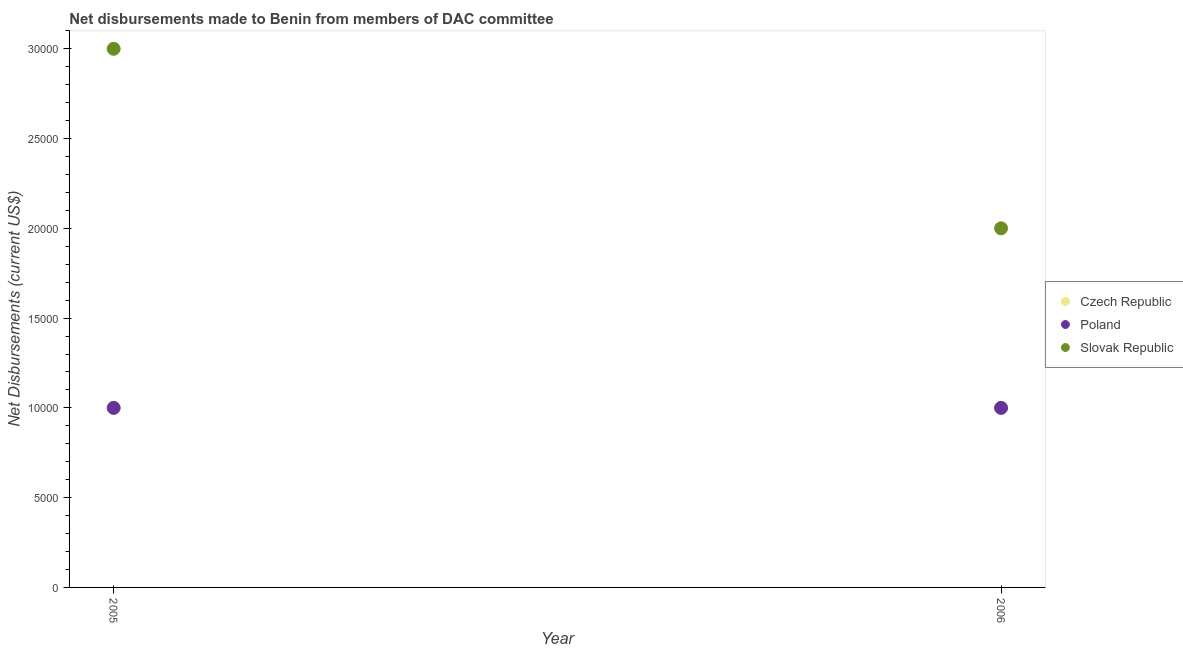How many different coloured dotlines are there?
Your response must be concise. 3. What is the net disbursements made by slovak republic in 2005?
Offer a terse response. 3.00e+04. Across all years, what is the maximum net disbursements made by poland?
Make the answer very short. 10000. Across all years, what is the minimum net disbursements made by slovak republic?
Ensure brevity in your answer.  2.00e+04. What is the total net disbursements made by czech republic in the graph?
Provide a short and direct response. 2.00e+04. What is the difference between the net disbursements made by poland in 2005 and that in 2006?
Give a very brief answer. 0. What is the difference between the net disbursements made by slovak republic in 2006 and the net disbursements made by czech republic in 2005?
Ensure brevity in your answer.  10000. In the year 2006, what is the difference between the net disbursements made by czech republic and net disbursements made by poland?
Provide a short and direct response. 0. In how many years, is the net disbursements made by poland greater than 19000 US$?
Give a very brief answer. 0. What is the ratio of the net disbursements made by slovak republic in 2005 to that in 2006?
Provide a succinct answer. 1.5. Is it the case that in every year, the sum of the net disbursements made by czech republic and net disbursements made by poland is greater than the net disbursements made by slovak republic?
Provide a short and direct response. No. Does the net disbursements made by poland monotonically increase over the years?
Your answer should be very brief. No. Is the net disbursements made by poland strictly greater than the net disbursements made by czech republic over the years?
Ensure brevity in your answer.  No. How many dotlines are there?
Provide a succinct answer. 3. How many years are there in the graph?
Offer a very short reply. 2. What is the difference between two consecutive major ticks on the Y-axis?
Your response must be concise. 5000. Are the values on the major ticks of Y-axis written in scientific E-notation?
Keep it short and to the point. No. Does the graph contain grids?
Ensure brevity in your answer.  No. Where does the legend appear in the graph?
Offer a terse response. Center right. How many legend labels are there?
Give a very brief answer. 3. What is the title of the graph?
Give a very brief answer. Net disbursements made to Benin from members of DAC committee. Does "Transport equipments" appear as one of the legend labels in the graph?
Your response must be concise. No. What is the label or title of the Y-axis?
Make the answer very short. Net Disbursements (current US$). What is the Net Disbursements (current US$) of Czech Republic in 2005?
Keep it short and to the point. 10000. What is the Net Disbursements (current US$) of Poland in 2006?
Offer a very short reply. 10000. Across all years, what is the maximum Net Disbursements (current US$) of Czech Republic?
Your answer should be very brief. 10000. Across all years, what is the maximum Net Disbursements (current US$) of Poland?
Your answer should be very brief. 10000. Across all years, what is the minimum Net Disbursements (current US$) in Czech Republic?
Provide a succinct answer. 10000. Across all years, what is the minimum Net Disbursements (current US$) of Slovak Republic?
Offer a very short reply. 2.00e+04. What is the total Net Disbursements (current US$) of Czech Republic in the graph?
Your answer should be compact. 2.00e+04. What is the total Net Disbursements (current US$) in Poland in the graph?
Make the answer very short. 2.00e+04. What is the total Net Disbursements (current US$) of Slovak Republic in the graph?
Your response must be concise. 5.00e+04. What is the difference between the Net Disbursements (current US$) of Poland in 2005 and that in 2006?
Keep it short and to the point. 0. What is the difference between the Net Disbursements (current US$) in Czech Republic in 2005 and the Net Disbursements (current US$) in Slovak Republic in 2006?
Your response must be concise. -10000. What is the average Net Disbursements (current US$) in Czech Republic per year?
Provide a short and direct response. 10000. What is the average Net Disbursements (current US$) of Slovak Republic per year?
Provide a succinct answer. 2.50e+04. In the year 2005, what is the difference between the Net Disbursements (current US$) of Czech Republic and Net Disbursements (current US$) of Poland?
Ensure brevity in your answer.  0. In the year 2005, what is the difference between the Net Disbursements (current US$) of Czech Republic and Net Disbursements (current US$) of Slovak Republic?
Your answer should be very brief. -2.00e+04. In the year 2006, what is the difference between the Net Disbursements (current US$) in Czech Republic and Net Disbursements (current US$) in Poland?
Make the answer very short. 0. What is the ratio of the Net Disbursements (current US$) in Poland in 2005 to that in 2006?
Keep it short and to the point. 1. What is the ratio of the Net Disbursements (current US$) in Slovak Republic in 2005 to that in 2006?
Provide a succinct answer. 1.5. What is the difference between the highest and the second highest Net Disbursements (current US$) of Czech Republic?
Offer a very short reply. 0. What is the difference between the highest and the second highest Net Disbursements (current US$) in Poland?
Provide a short and direct response. 0. What is the difference between the highest and the second highest Net Disbursements (current US$) in Slovak Republic?
Provide a succinct answer. 10000. What is the difference between the highest and the lowest Net Disbursements (current US$) of Czech Republic?
Your answer should be very brief. 0. What is the difference between the highest and the lowest Net Disbursements (current US$) in Slovak Republic?
Offer a terse response. 10000. 